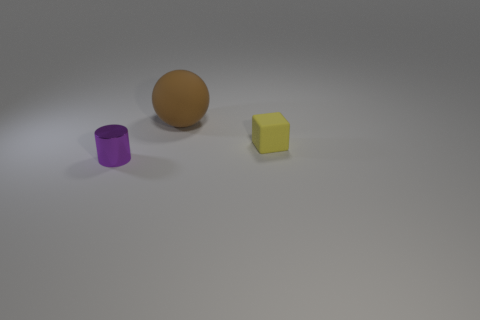Add 3 cubes. How many objects exist? 6 Subtract all cylinders. How many objects are left? 2 Subtract all brown cubes. How many yellow balls are left? 0 Subtract all tiny cubes. Subtract all tiny yellow cubes. How many objects are left? 1 Add 1 tiny yellow objects. How many tiny yellow objects are left? 2 Add 2 tiny purple rubber cubes. How many tiny purple rubber cubes exist? 2 Subtract 0 blue balls. How many objects are left? 3 